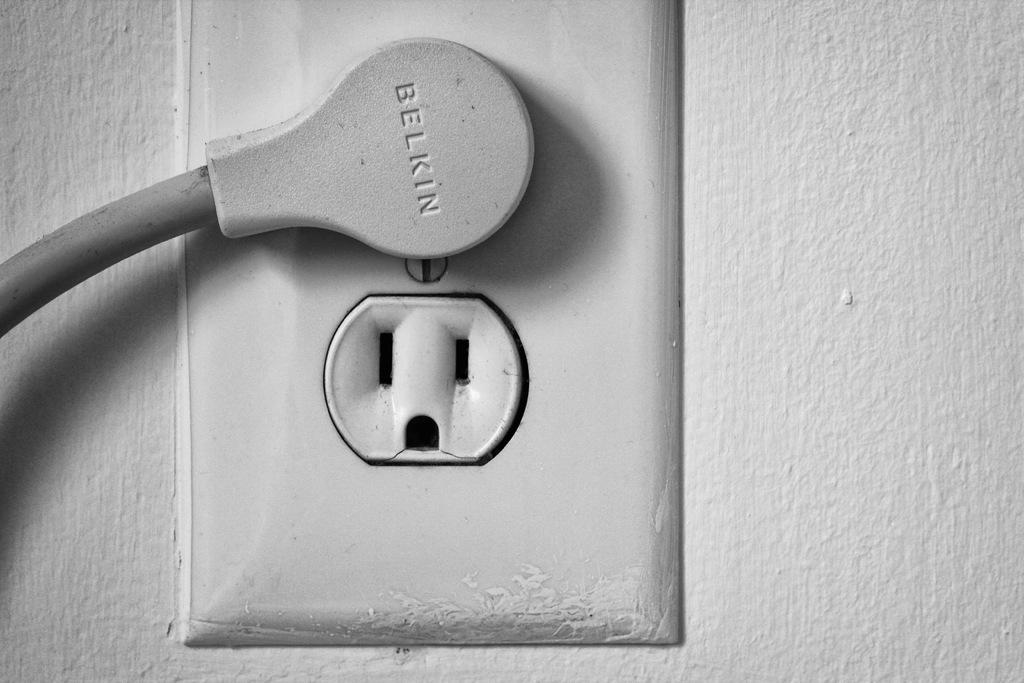<image>
Create a compact narrative representing the image presented. A Belkin brand cord is plugged into an electrical socket. 